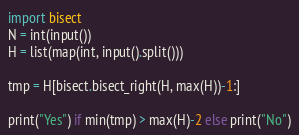<code> <loc_0><loc_0><loc_500><loc_500><_Python_>import bisect
N = int(input())
H = list(map(int, input().split()))

tmp = H[bisect.bisect_right(H, max(H))-1:]

print("Yes") if min(tmp) > max(H)-2 else print("No")</code> 